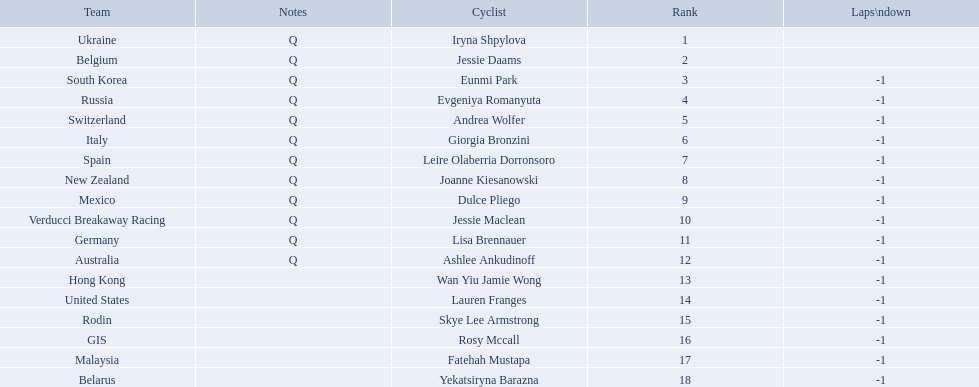Who competed in the race? Iryna Shpylova, Jessie Daams, Eunmi Park, Evgeniya Romanyuta, Andrea Wolfer, Giorgia Bronzini, Leire Olaberria Dorronsoro, Joanne Kiesanowski, Dulce Pliego, Jessie Maclean, Lisa Brennauer, Ashlee Ankudinoff, Wan Yiu Jamie Wong, Lauren Franges, Skye Lee Armstrong, Rosy Mccall, Fatehah Mustapa, Yekatsiryna Barazna. Who ranked highest in the race? Iryna Shpylova. Who are all of the cyclists in this race? Iryna Shpylova, Jessie Daams, Eunmi Park, Evgeniya Romanyuta, Andrea Wolfer, Giorgia Bronzini, Leire Olaberria Dorronsoro, Joanne Kiesanowski, Dulce Pliego, Jessie Maclean, Lisa Brennauer, Ashlee Ankudinoff, Wan Yiu Jamie Wong, Lauren Franges, Skye Lee Armstrong, Rosy Mccall, Fatehah Mustapa, Yekatsiryna Barazna. Of these, which one has the lowest numbered rank? Iryna Shpylova. 